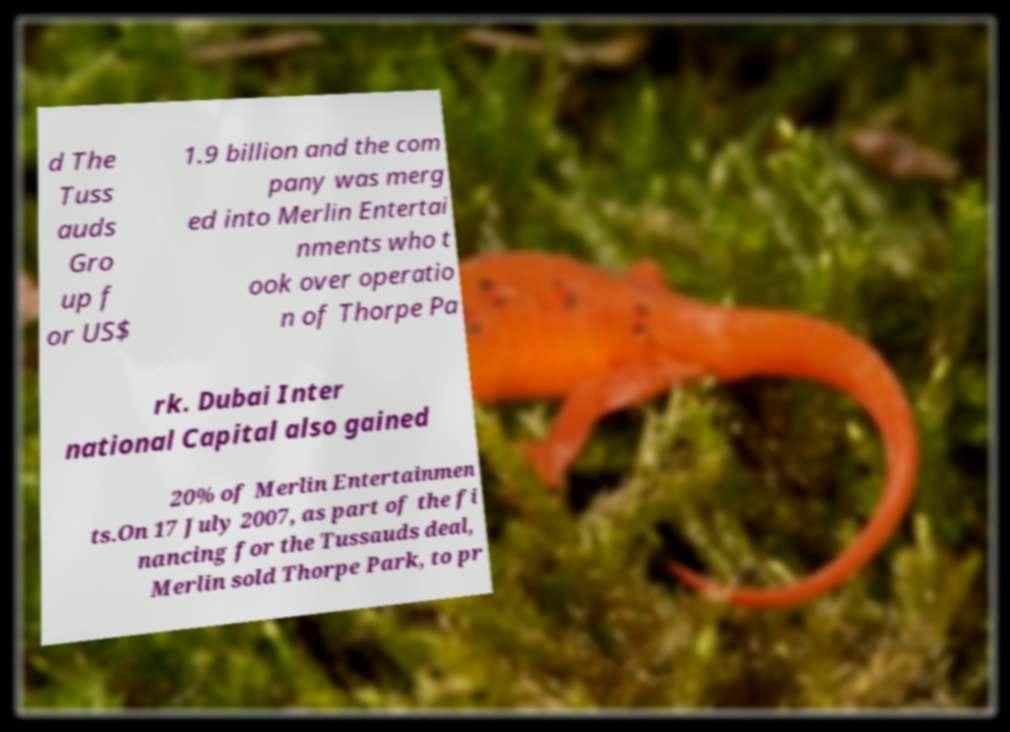Can you read and provide the text displayed in the image?This photo seems to have some interesting text. Can you extract and type it out for me? d The Tuss auds Gro up f or US$ 1.9 billion and the com pany was merg ed into Merlin Entertai nments who t ook over operatio n of Thorpe Pa rk. Dubai Inter national Capital also gained 20% of Merlin Entertainmen ts.On 17 July 2007, as part of the fi nancing for the Tussauds deal, Merlin sold Thorpe Park, to pr 